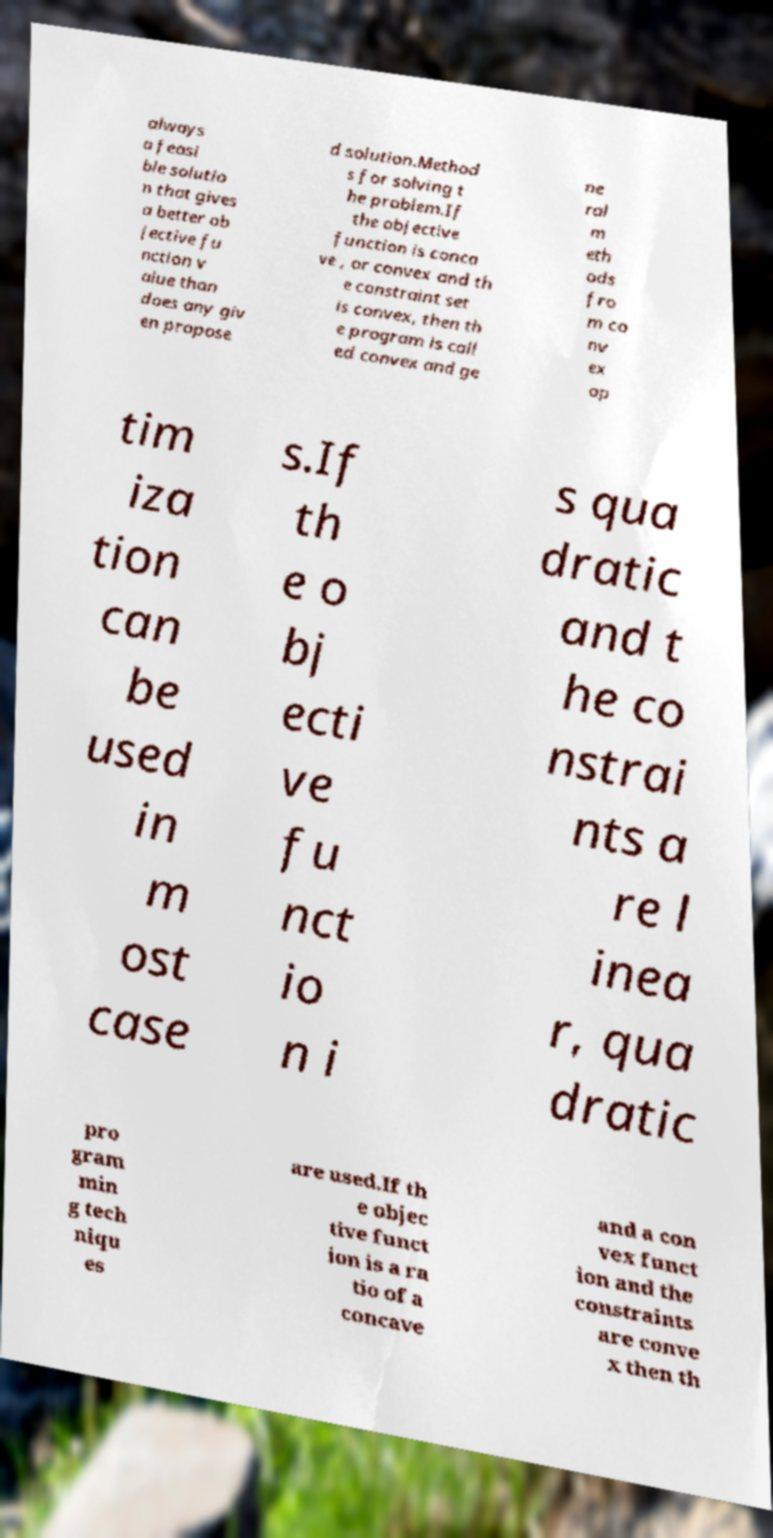Could you assist in decoding the text presented in this image and type it out clearly? always a feasi ble solutio n that gives a better ob jective fu nction v alue than does any giv en propose d solution.Method s for solving t he problem.If the objective function is conca ve , or convex and th e constraint set is convex, then th e program is call ed convex and ge ne ral m eth ods fro m co nv ex op tim iza tion can be used in m ost case s.If th e o bj ecti ve fu nct io n i s qua dratic and t he co nstrai nts a re l inea r, qua dratic pro gram min g tech niqu es are used.If th e objec tive funct ion is a ra tio of a concave and a con vex funct ion and the constraints are conve x then th 